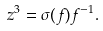<formula> <loc_0><loc_0><loc_500><loc_500>z ^ { 3 } = \sigma ( f ) f ^ { - 1 } .</formula> 